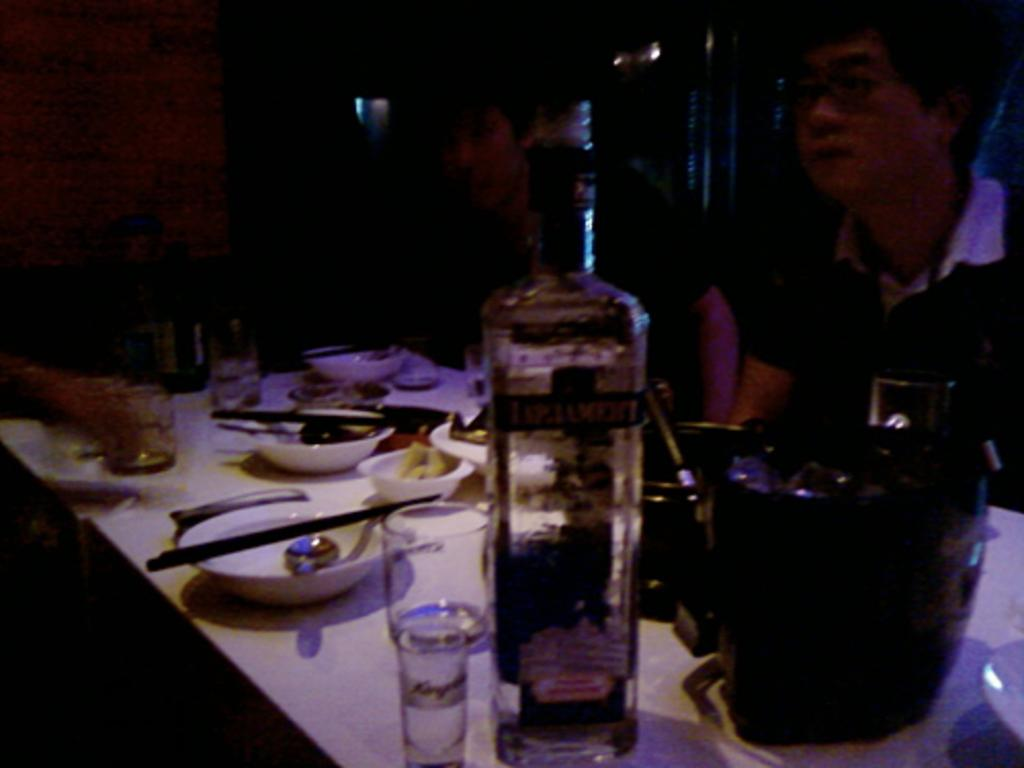What is the main piece of furniture in the image? There is a table in the image. What objects are placed on the table? There are bowls, glasses, and bottles on the table. What is inside the bowls? There is food in the bowls. How many people are present in the image? There are two persons sitting on chairs behind the table. What type of pollution can be seen in the image? There is no pollution visible in the image; it features a table with bowls, glasses, and bottles, along with two persons sitting on chairs. 